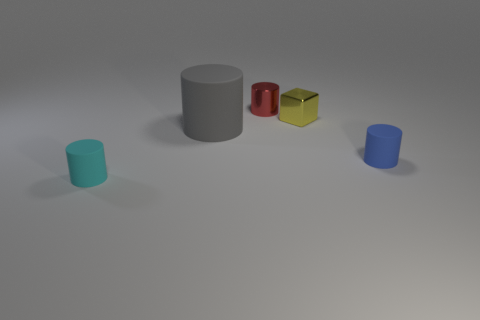Subtract all metallic cylinders. How many cylinders are left? 3 Subtract all gray cylinders. How many cylinders are left? 3 Add 1 yellow cubes. How many objects exist? 6 Subtract all cylinders. How many objects are left? 1 Subtract all gray cylinders. Subtract all red blocks. How many cylinders are left? 3 Add 5 blocks. How many blocks are left? 6 Add 4 small cylinders. How many small cylinders exist? 7 Subtract 0 brown cylinders. How many objects are left? 5 Subtract all tiny metal blocks. Subtract all tiny metal objects. How many objects are left? 2 